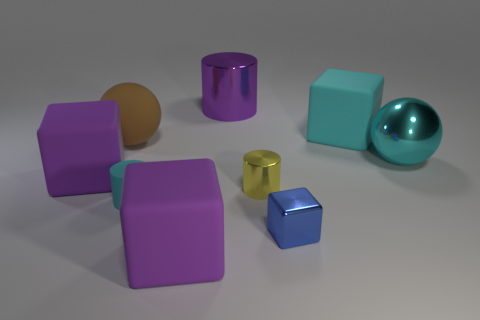Add 1 large cyan rubber cubes. How many objects exist? 10 Subtract all cylinders. How many objects are left? 6 Subtract 1 cyan blocks. How many objects are left? 8 Subtract all cyan things. Subtract all small gray shiny cylinders. How many objects are left? 6 Add 2 blue metal blocks. How many blue metal blocks are left? 3 Add 2 small red rubber blocks. How many small red rubber blocks exist? 2 